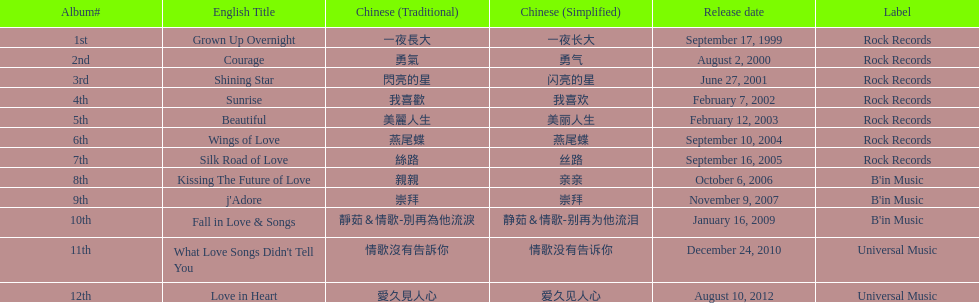Which was the only album to be released by b'in music in an even-numbered year? Kissing The Future of Love. 